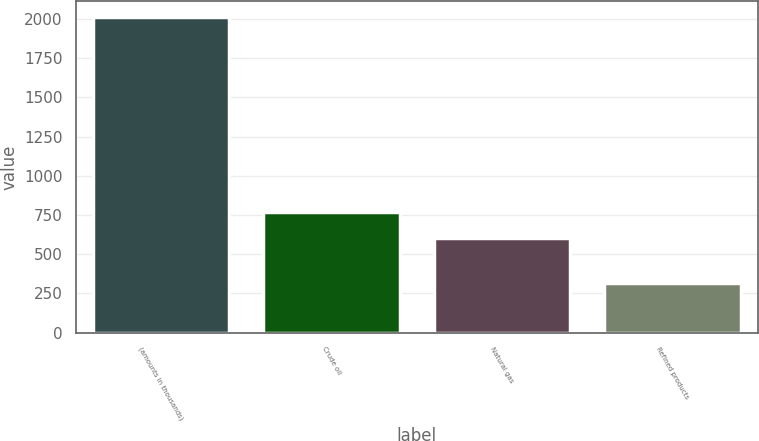Convert chart to OTSL. <chart><loc_0><loc_0><loc_500><loc_500><bar_chart><fcel>(amounts in thousands)<fcel>Crude oil<fcel>Natural gas<fcel>Refined products<nl><fcel>2012<fcel>769.8<fcel>600<fcel>314<nl></chart> 